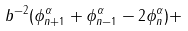<formula> <loc_0><loc_0><loc_500><loc_500>b ^ { - 2 } ( \phi ^ { \alpha } _ { n + 1 } + \phi ^ { \alpha } _ { n - 1 } - 2 \phi ^ { \alpha } _ { n } ) +</formula> 